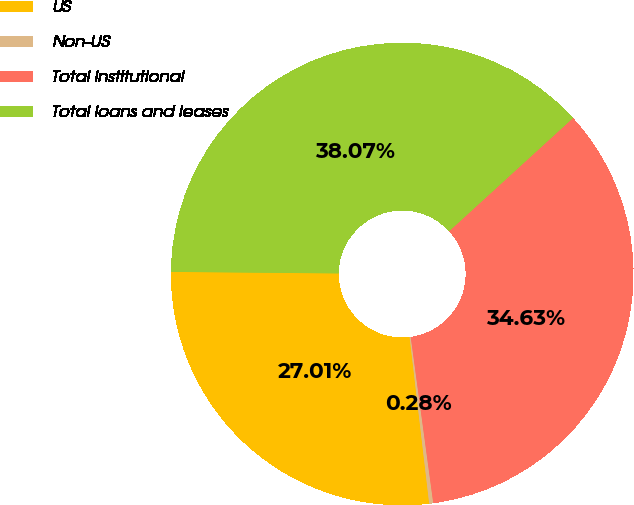Convert chart to OTSL. <chart><loc_0><loc_0><loc_500><loc_500><pie_chart><fcel>US<fcel>Non-US<fcel>Total institutional<fcel>Total loans and leases<nl><fcel>27.01%<fcel>0.28%<fcel>34.63%<fcel>38.07%<nl></chart> 